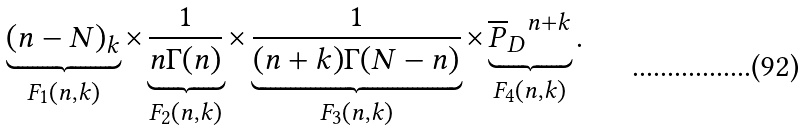<formula> <loc_0><loc_0><loc_500><loc_500>\underbrace { ( n - N ) _ { k } } _ { F _ { 1 } ( n , k ) } \times \underbrace { \frac { 1 } { n \Gamma ( n ) } } _ { F _ { 2 } ( n , k ) } \times \underbrace { \frac { 1 } { ( n + k ) \Gamma ( N - n ) } } _ { F _ { 3 } ( n , k ) } \times \underbrace { { \overline { P } _ { D } } ^ { n + k } } _ { F _ { 4 } ( n , k ) } .</formula> 